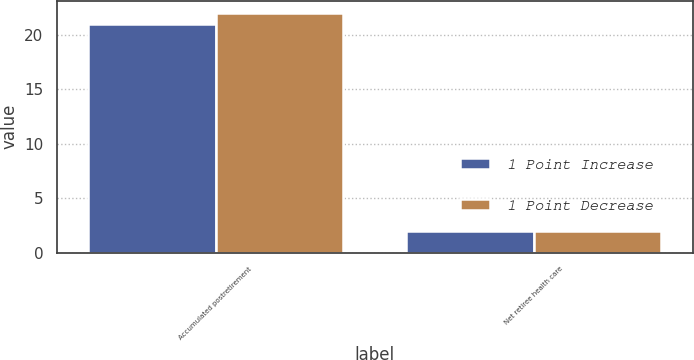Convert chart. <chart><loc_0><loc_0><loc_500><loc_500><stacked_bar_chart><ecel><fcel>Accumulated postretirement<fcel>Net retiree health care<nl><fcel>1 Point Increase<fcel>21<fcel>2<nl><fcel>1 Point Decrease<fcel>22<fcel>2<nl></chart> 